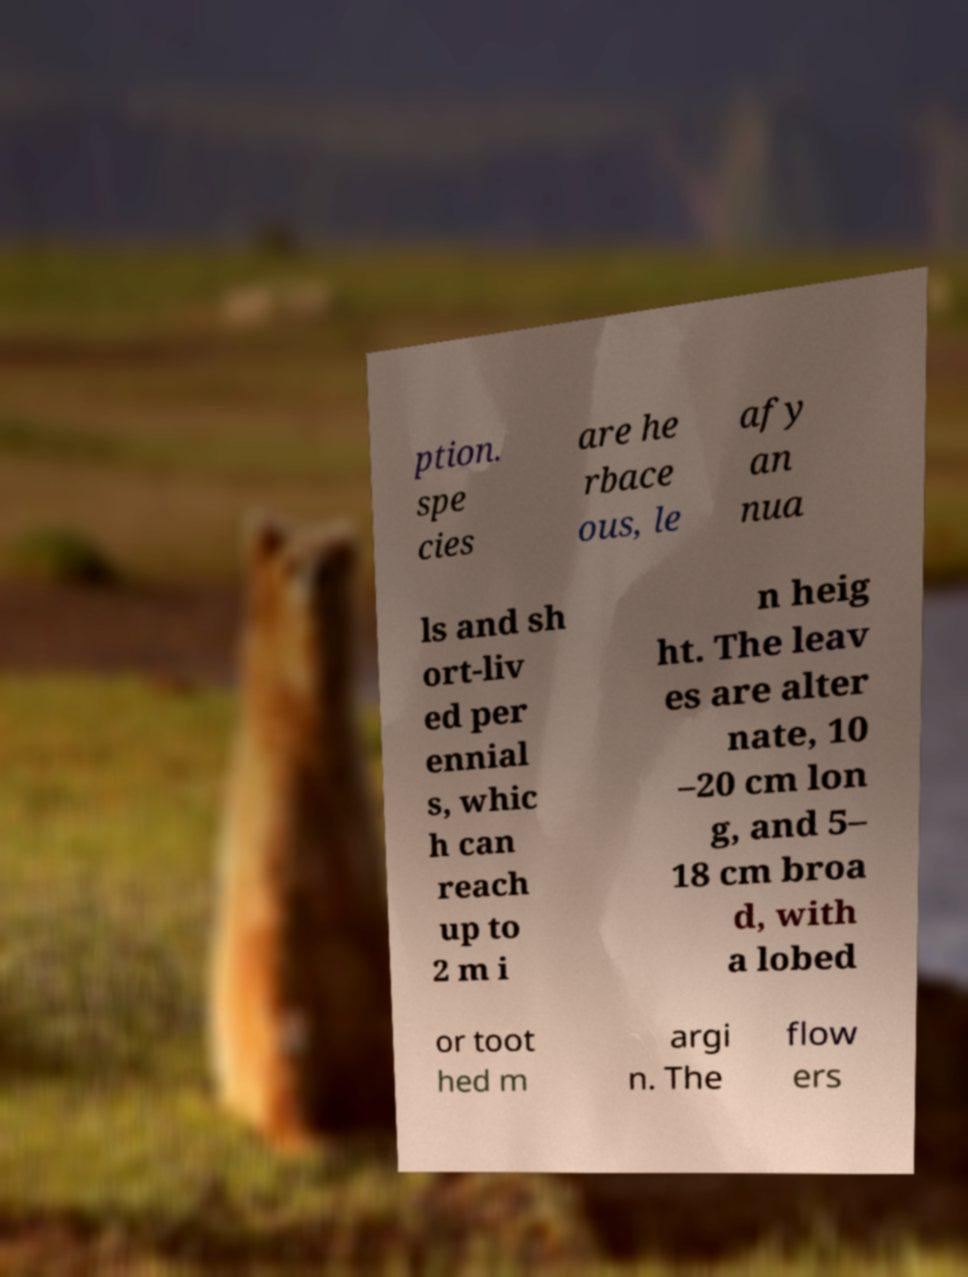Could you assist in decoding the text presented in this image and type it out clearly? ption. spe cies are he rbace ous, le afy an nua ls and sh ort-liv ed per ennial s, whic h can reach up to 2 m i n heig ht. The leav es are alter nate, 10 –20 cm lon g, and 5– 18 cm broa d, with a lobed or toot hed m argi n. The flow ers 